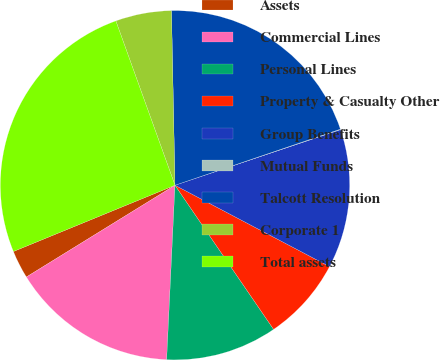<chart> <loc_0><loc_0><loc_500><loc_500><pie_chart><fcel>Assets<fcel>Commercial Lines<fcel>Personal Lines<fcel>Property & Casualty Other<fcel>Group Benefits<fcel>Mutual Funds<fcel>Talcott Resolution<fcel>Corporate 1<fcel>Total assets<nl><fcel>2.61%<fcel>15.44%<fcel>10.31%<fcel>7.74%<fcel>12.87%<fcel>0.05%<fcel>20.12%<fcel>5.18%<fcel>25.7%<nl></chart> 